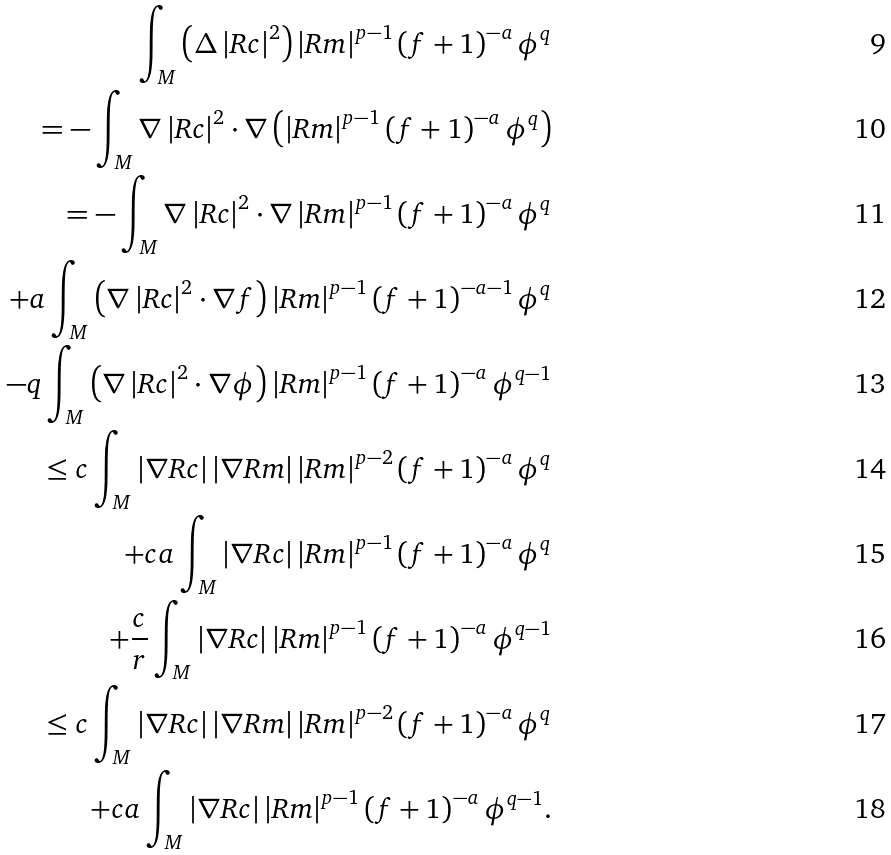<formula> <loc_0><loc_0><loc_500><loc_500>\int _ { M } \left ( \Delta \left | R c \right | ^ { 2 } \right ) \left | R m \right | ^ { p - 1 } \left ( f + 1 \right ) ^ { - a } \phi ^ { q } \\ = - \int _ { M } \nabla \left | R c \right | ^ { 2 } \cdot \nabla \left ( \left | R m \right | ^ { p - 1 } \left ( f + 1 \right ) ^ { - a } \phi ^ { q } \right ) \\ = - \int _ { M } \nabla \left | R c \right | ^ { 2 } \cdot \nabla \left | R m \right | ^ { p - 1 } \left ( f + 1 \right ) ^ { - a } \phi ^ { q } \\ + a \int _ { M } \left ( \nabla \left | R c \right | ^ { 2 } \cdot \nabla f \right ) \left | R m \right | ^ { p - 1 } \left ( f + 1 \right ) ^ { - a - 1 } \phi ^ { q } \\ - q \int _ { M } \left ( \nabla \left | R c \right | ^ { 2 } \cdot \nabla \phi \right ) \left | R m \right | ^ { p - 1 } \left ( f + 1 \right ) ^ { - a } \phi ^ { q - 1 } \\ \leq c \int _ { M } \left | \nabla R c \right | \left | \nabla R m \right | \left | R m \right | ^ { p - 2 } \left ( f + 1 \right ) ^ { - a } \phi ^ { q } \\ + c a \int _ { M } \left | \nabla R c \right | \left | R m \right | ^ { p - 1 } \left ( f + 1 \right ) ^ { - a } \phi ^ { q } \\ + \frac { c } { r } \int _ { M } \left | \nabla R c \right | \left | R m \right | ^ { p - 1 } \left ( f + 1 \right ) ^ { - a } \phi ^ { q - 1 } \\ \leq c \int _ { M } \left | \nabla R c \right | \left | \nabla R m \right | \left | R m \right | ^ { p - 2 } \left ( f + 1 \right ) ^ { - a } \phi ^ { q } \\ + c a \int _ { M } \left | \nabla R c \right | \left | R m \right | ^ { p - 1 } \left ( f + 1 \right ) ^ { - a } \phi ^ { q - 1 } .</formula> 